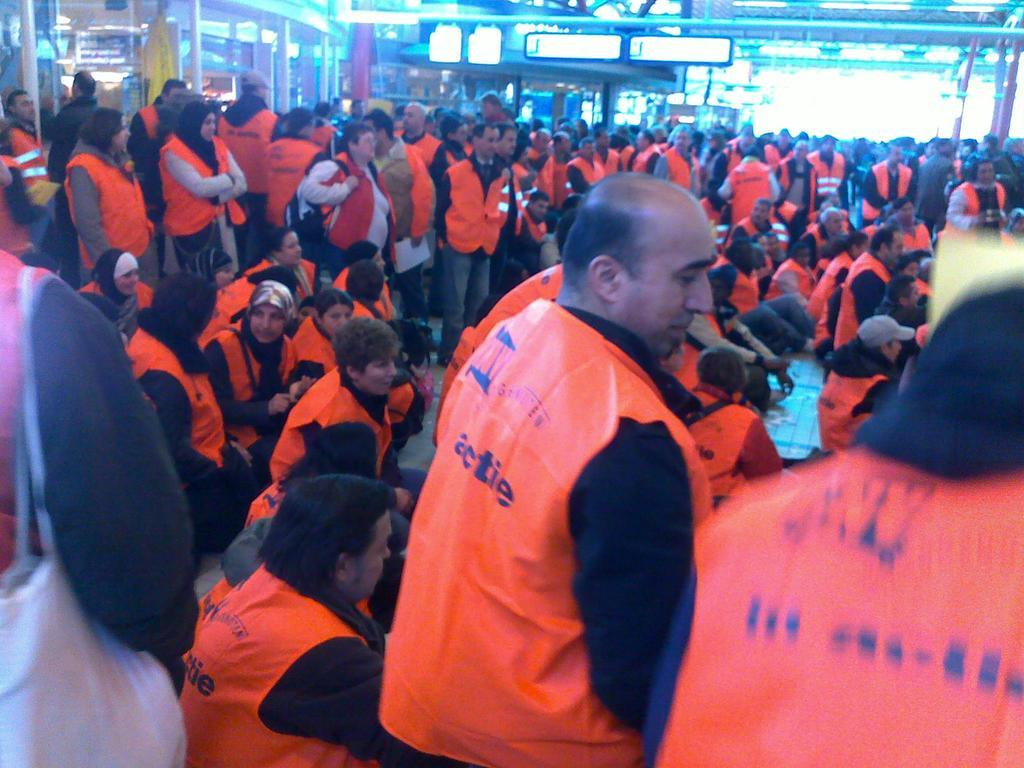How many people are in the image? There are many people in the image. What are the people doing in the image? The people are standing and sitting in various places. What are the people wearing in the image? The people are wearing safety jackets. Where was the image taken? The image appears to be taken inside a mall. How many slaves are visible in the image? There are no slaves present in the image; the people are wearing safety jackets, which suggests they might be working in a professional capacity. What type of beetle can be seen crawling on the floor in the image? There is no beetle visible in the image; the focus is on the people and their activities. 